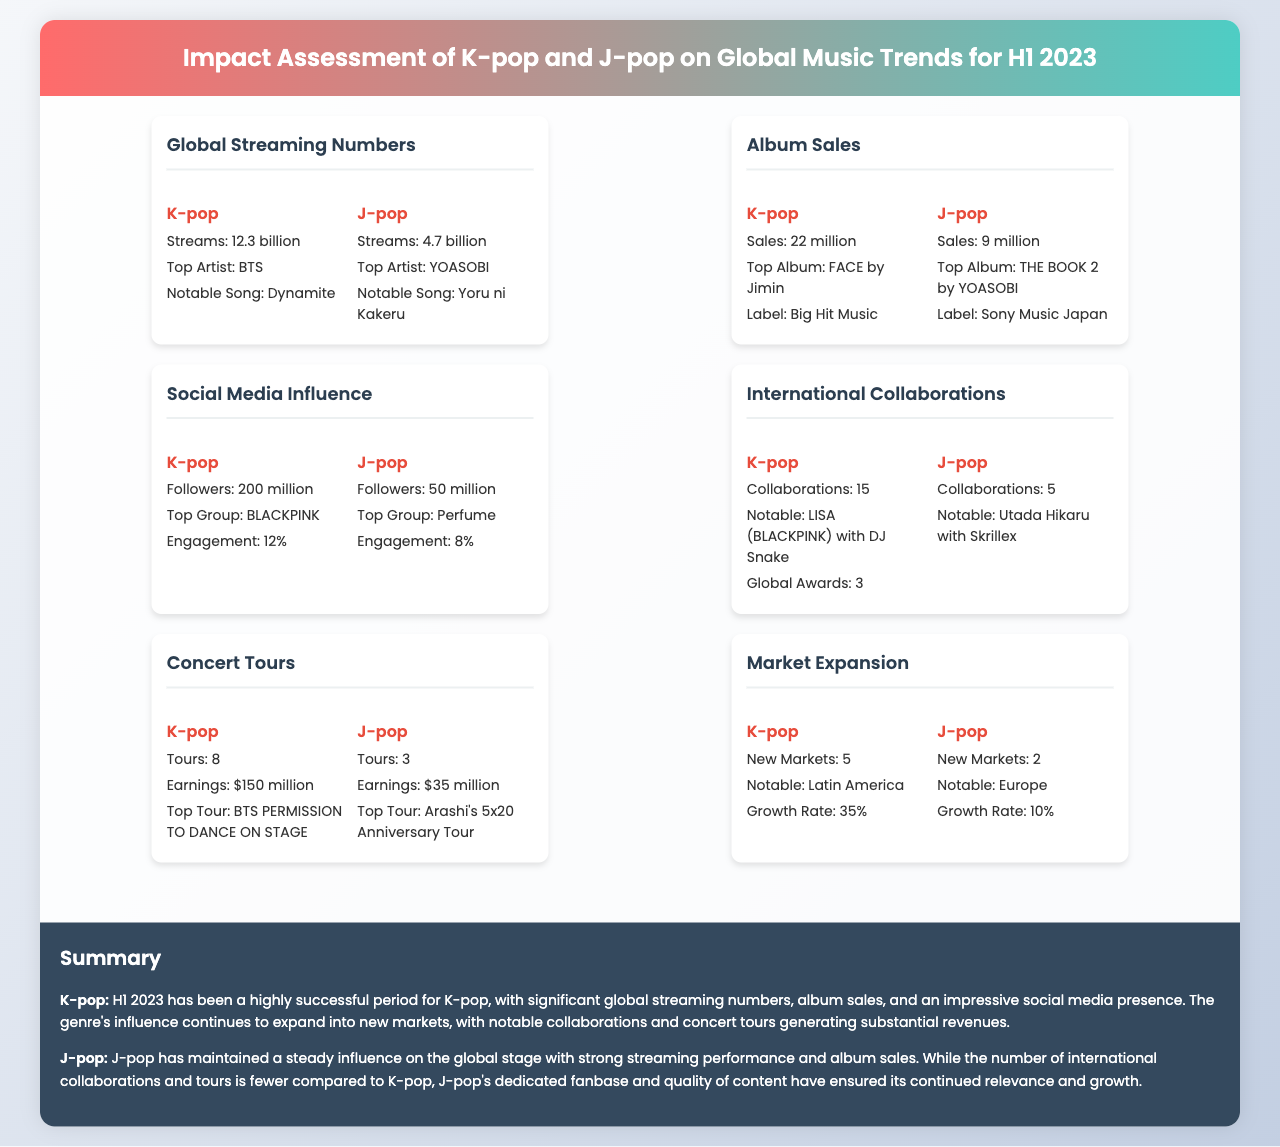What were the streaming numbers for K-pop? The streaming numbers for K-pop is stated in the document as 12.3 billion.
Answer: 12.3 billion Who is the top artist in J-pop? The document specifies that the top artist in J-pop is YOASOBI.
Answer: YOASOBI What was the total number of tours for K-pop? The total number of tours for K-pop is listed as 8 in the document.
Answer: 8 Which region did K-pop notably expand into? The document mentions that K-pop notably expanded into Latin America.
Answer: Latin America What was the album sales figure for J-pop? The document indicates that J-pop had album sales of 9 million.
Answer: 9 million How much did K-pop concert tours earn? The document states that K-pop concert tours earnings amounted to 150 million dollars.
Answer: $150 million What is the engagement rate of J-pop's social media influence? The engagement rate for J-pop's social media influence is noted as 8%.
Answer: 8% How many collaborations did J-pop have in H1 2023? The document specifies that J-pop had 5 collaborations during H1 2023.
Answer: 5 What is the top album for K-pop? The document identifies the top album for K-pop as FACE by Jimin.
Answer: FACE by Jimin 